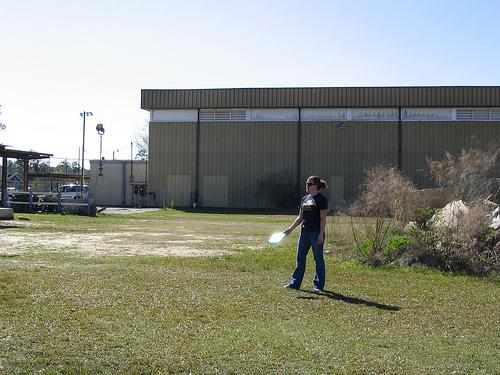Question: what gender is the person?
Choices:
A. Male.
B. Transgender.
C. Female.
D. Can't tell.
Answer with the letter. Answer: C Question: who is holding the frisbee?
Choices:
A. The player.
B. The woman.
C. The girl.
D. The adult.
Answer with the letter. Answer: B Question: where is the person standing?
Choices:
A. Parking lot.
B. Field.
C. Beach.
D. Street.
Answer with the letter. Answer: B Question: what is on top of the tallest pole in the background?
Choices:
A. A flag.
B. Lights.
C. A decoration.
D. A bird.
Answer with the letter. Answer: B Question: what is the color of the person's shirt?
Choices:
A. Black.
B. Gray.
C. Brown.
D. Red.
Answer with the letter. Answer: A Question: what is the color of the stripe across the building?
Choices:
A. Cream.
B. White.
C. Black.
D. Blue.
Answer with the letter. Answer: B 